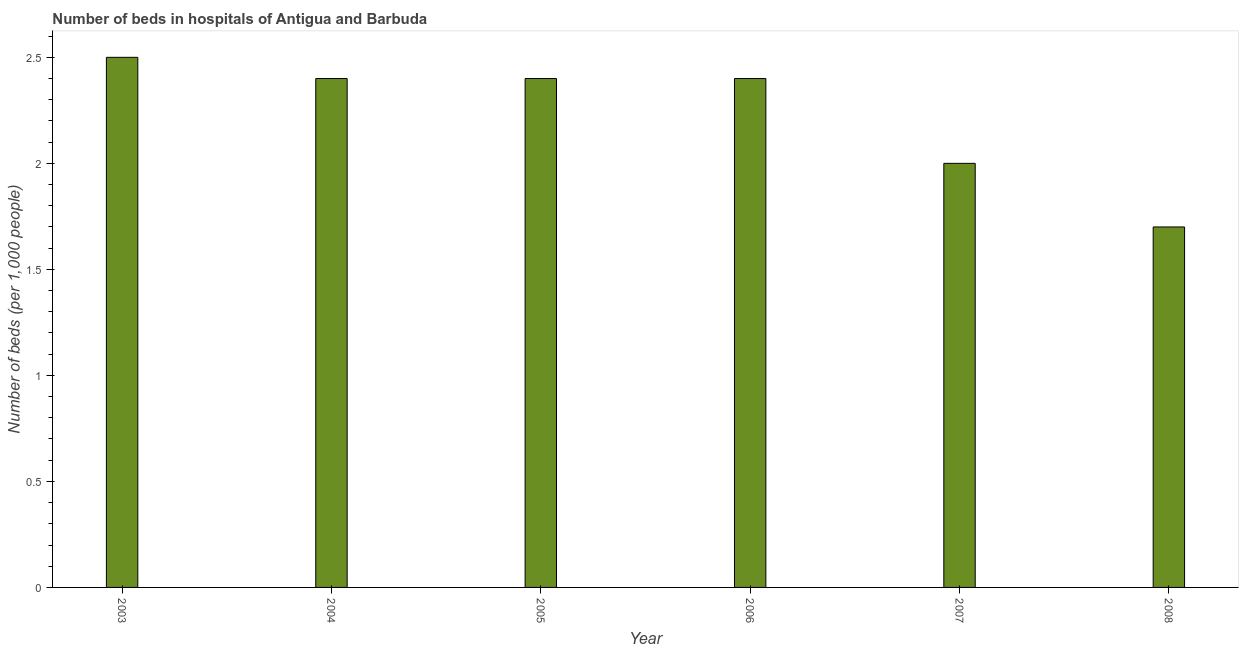Does the graph contain any zero values?
Provide a short and direct response. No. What is the title of the graph?
Your answer should be very brief. Number of beds in hospitals of Antigua and Barbuda. What is the label or title of the Y-axis?
Keep it short and to the point. Number of beds (per 1,0 people). What is the number of hospital beds in 2008?
Ensure brevity in your answer.  1.7. In which year was the number of hospital beds maximum?
Keep it short and to the point. 2003. In which year was the number of hospital beds minimum?
Make the answer very short. 2008. What is the sum of the number of hospital beds?
Provide a succinct answer. 13.4. What is the difference between the number of hospital beds in 2005 and 2007?
Your answer should be very brief. 0.4. What is the average number of hospital beds per year?
Your answer should be compact. 2.23. What is the median number of hospital beds?
Provide a succinct answer. 2.4. Do a majority of the years between 2007 and 2004 (inclusive) have number of hospital beds greater than 0.8 %?
Give a very brief answer. Yes. What is the ratio of the number of hospital beds in 2007 to that in 2008?
Offer a very short reply. 1.18. Is the number of hospital beds in 2004 less than that in 2007?
Offer a very short reply. No. What is the difference between the highest and the second highest number of hospital beds?
Provide a short and direct response. 0.1. What is the difference between the highest and the lowest number of hospital beds?
Give a very brief answer. 0.8. In how many years, is the number of hospital beds greater than the average number of hospital beds taken over all years?
Provide a succinct answer. 4. Are all the bars in the graph horizontal?
Make the answer very short. No. Are the values on the major ticks of Y-axis written in scientific E-notation?
Offer a very short reply. No. What is the Number of beds (per 1,000 people) of 2003?
Make the answer very short. 2.5. What is the Number of beds (per 1,000 people) of 2005?
Make the answer very short. 2.4. What is the Number of beds (per 1,000 people) in 2006?
Your response must be concise. 2.4. What is the difference between the Number of beds (per 1,000 people) in 2003 and 2005?
Your response must be concise. 0.1. What is the difference between the Number of beds (per 1,000 people) in 2003 and 2007?
Provide a short and direct response. 0.5. What is the difference between the Number of beds (per 1,000 people) in 2003 and 2008?
Keep it short and to the point. 0.8. What is the difference between the Number of beds (per 1,000 people) in 2004 and 2006?
Give a very brief answer. 0. What is the difference between the Number of beds (per 1,000 people) in 2004 and 2007?
Make the answer very short. 0.4. What is the difference between the Number of beds (per 1,000 people) in 2004 and 2008?
Your answer should be very brief. 0.7. What is the difference between the Number of beds (per 1,000 people) in 2005 and 2008?
Your answer should be very brief. 0.7. What is the difference between the Number of beds (per 1,000 people) in 2006 and 2007?
Keep it short and to the point. 0.4. What is the ratio of the Number of beds (per 1,000 people) in 2003 to that in 2004?
Offer a terse response. 1.04. What is the ratio of the Number of beds (per 1,000 people) in 2003 to that in 2005?
Offer a very short reply. 1.04. What is the ratio of the Number of beds (per 1,000 people) in 2003 to that in 2006?
Offer a very short reply. 1.04. What is the ratio of the Number of beds (per 1,000 people) in 2003 to that in 2007?
Provide a succinct answer. 1.25. What is the ratio of the Number of beds (per 1,000 people) in 2003 to that in 2008?
Keep it short and to the point. 1.47. What is the ratio of the Number of beds (per 1,000 people) in 2004 to that in 2008?
Your response must be concise. 1.41. What is the ratio of the Number of beds (per 1,000 people) in 2005 to that in 2006?
Offer a terse response. 1. What is the ratio of the Number of beds (per 1,000 people) in 2005 to that in 2007?
Provide a short and direct response. 1.2. What is the ratio of the Number of beds (per 1,000 people) in 2005 to that in 2008?
Your response must be concise. 1.41. What is the ratio of the Number of beds (per 1,000 people) in 2006 to that in 2008?
Your answer should be very brief. 1.41. What is the ratio of the Number of beds (per 1,000 people) in 2007 to that in 2008?
Give a very brief answer. 1.18. 